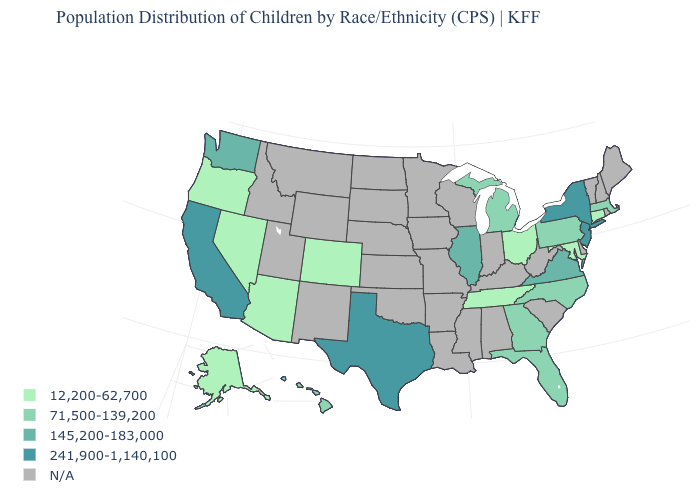Which states have the highest value in the USA?
Write a very short answer. California, New Jersey, New York, Texas. What is the value of South Carolina?
Concise answer only. N/A. Among the states that border Maryland , does Pennsylvania have the lowest value?
Write a very short answer. Yes. What is the value of Rhode Island?
Keep it brief. N/A. How many symbols are there in the legend?
Quick response, please. 5. How many symbols are there in the legend?
Quick response, please. 5. Name the states that have a value in the range 241,900-1,140,100?
Be succinct. California, New Jersey, New York, Texas. What is the highest value in the MidWest ?
Answer briefly. 145,200-183,000. Which states hav the highest value in the MidWest?
Keep it brief. Illinois. Name the states that have a value in the range 241,900-1,140,100?
Keep it brief. California, New Jersey, New York, Texas. What is the value of Indiana?
Quick response, please. N/A. Is the legend a continuous bar?
Keep it brief. No. Which states have the lowest value in the Northeast?
Be succinct. Connecticut. Name the states that have a value in the range 145,200-183,000?
Be succinct. Illinois, Virginia, Washington. 